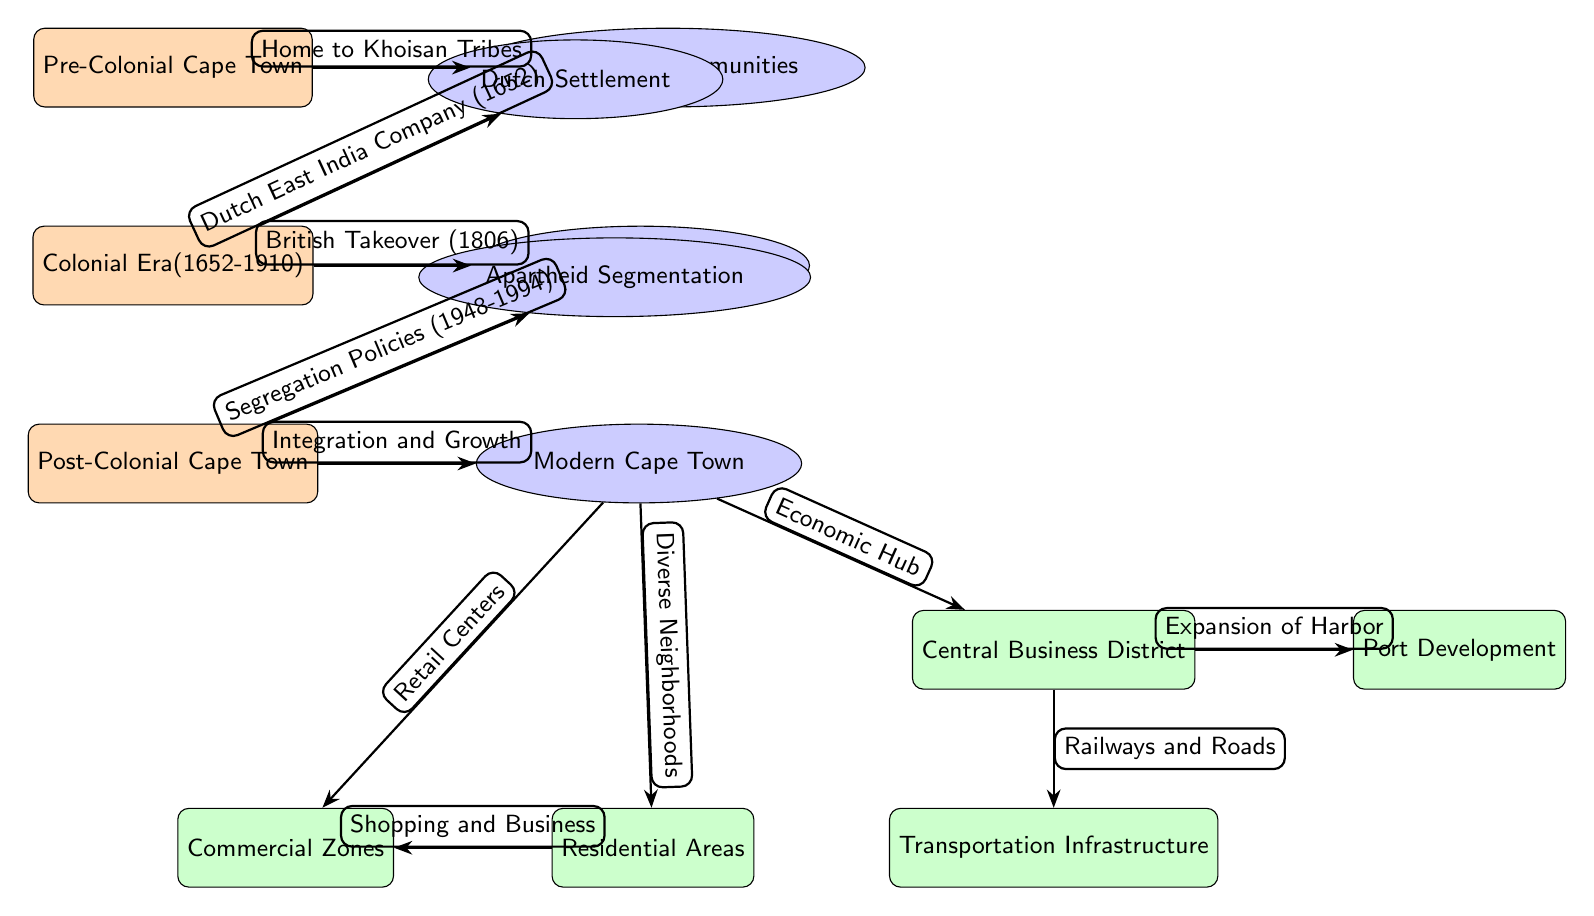What is the first era represented in the diagram? The diagram starts with the node labeled "Pre-Colonial Cape Town," which is the first era shown.
Answer: Pre-Colonial Cape Town How many aspects are linked to the colonial era? The colonial era node has two linked aspects: "Dutch Settlement" and "British Colonial Rule." Counting these gives a total of two aspects connected to the Colonial Era.
Answer: 2 What term describes the communities before colonization? The aspect linked to the "Pre-Colonial Cape Town" node describes the "Indigenous Communities," which represents the groups before colonization.
Answer: Indigenous Communities What significant event is signified by the arrow from the Colonial Era? The arrow from the colonial era node points to "Dutch Settlement," which indicates the founding of the Dutch colony by the Dutch East India Company.
Answer: Dutch East India Company (1652) Which aspect of Post-Colonial Cape Town relates to urban segregation? The node labeled "Apartheid Segmentation" is the aspect representing urban segregation policies. It is connected to the post-colonial era, reflecting the consequences of certain policies in urban planning.
Answer: Apartheid Segmentation How does modern Cape Town’s urban layout relate to its economic center? The aspect "Central Business District" is connected to "Modern Cape Town," indicating that the layout includes a designated area for economic activities and commercial interests. This demonstrates the importance of economic hubs in modern urban planning.
Answer: Central Business District What aspect follows the node related to segregation in the timeline of urban development? The arrow leading from "Post-Colonial Cape Town" to "Modern Cape Town" signifies the evolution from segregation policies to a more integrated urban fabric, highlighting growth and development after the apartheid era.
Answer: Integration and Growth What development is indicated by the connection from the Central Business District? The "Expansion of Harbor" node follows from the "Central Business District," indicating a relationship between the economic hub and port development, suggesting that economic activity has spurred port growth.
Answer: Expansion of Harbor 